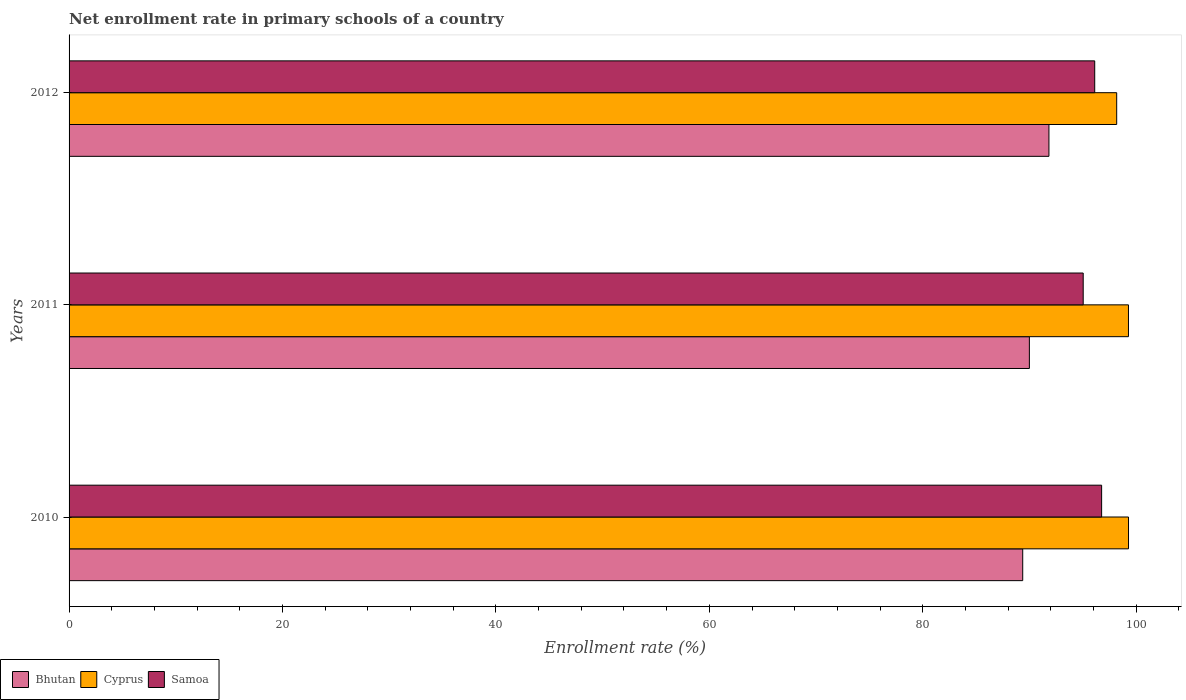How many different coloured bars are there?
Your response must be concise. 3. How many groups of bars are there?
Keep it short and to the point. 3. Are the number of bars on each tick of the Y-axis equal?
Make the answer very short. Yes. How many bars are there on the 1st tick from the top?
Keep it short and to the point. 3. How many bars are there on the 1st tick from the bottom?
Provide a short and direct response. 3. What is the label of the 3rd group of bars from the top?
Make the answer very short. 2010. What is the enrollment rate in primary schools in Bhutan in 2010?
Offer a terse response. 89.37. Across all years, what is the maximum enrollment rate in primary schools in Bhutan?
Your answer should be very brief. 91.83. Across all years, what is the minimum enrollment rate in primary schools in Cyprus?
Provide a short and direct response. 98.18. In which year was the enrollment rate in primary schools in Cyprus maximum?
Your response must be concise. 2010. What is the total enrollment rate in primary schools in Cyprus in the graph?
Ensure brevity in your answer.  296.74. What is the difference between the enrollment rate in primary schools in Cyprus in 2011 and that in 2012?
Offer a very short reply. 1.1. What is the difference between the enrollment rate in primary schools in Bhutan in 2011 and the enrollment rate in primary schools in Cyprus in 2012?
Ensure brevity in your answer.  -8.18. What is the average enrollment rate in primary schools in Samoa per year?
Ensure brevity in your answer.  95.97. In the year 2011, what is the difference between the enrollment rate in primary schools in Bhutan and enrollment rate in primary schools in Cyprus?
Your response must be concise. -9.29. What is the ratio of the enrollment rate in primary schools in Samoa in 2011 to that in 2012?
Give a very brief answer. 0.99. Is the difference between the enrollment rate in primary schools in Bhutan in 2010 and 2011 greater than the difference between the enrollment rate in primary schools in Cyprus in 2010 and 2011?
Make the answer very short. No. What is the difference between the highest and the second highest enrollment rate in primary schools in Samoa?
Your answer should be compact. 0.65. What is the difference between the highest and the lowest enrollment rate in primary schools in Cyprus?
Your answer should be compact. 1.11. In how many years, is the enrollment rate in primary schools in Samoa greater than the average enrollment rate in primary schools in Samoa taken over all years?
Offer a very short reply. 2. What does the 1st bar from the top in 2011 represents?
Make the answer very short. Samoa. What does the 3rd bar from the bottom in 2012 represents?
Offer a very short reply. Samoa. Is it the case that in every year, the sum of the enrollment rate in primary schools in Samoa and enrollment rate in primary schools in Bhutan is greater than the enrollment rate in primary schools in Cyprus?
Provide a succinct answer. Yes. Are all the bars in the graph horizontal?
Your answer should be compact. Yes. Does the graph contain any zero values?
Your response must be concise. No. Does the graph contain grids?
Make the answer very short. No. Where does the legend appear in the graph?
Offer a terse response. Bottom left. What is the title of the graph?
Give a very brief answer. Net enrollment rate in primary schools of a country. Does "French Polynesia" appear as one of the legend labels in the graph?
Ensure brevity in your answer.  No. What is the label or title of the X-axis?
Ensure brevity in your answer.  Enrollment rate (%). What is the label or title of the Y-axis?
Your answer should be compact. Years. What is the Enrollment rate (%) of Bhutan in 2010?
Keep it short and to the point. 89.37. What is the Enrollment rate (%) in Cyprus in 2010?
Keep it short and to the point. 99.29. What is the Enrollment rate (%) in Samoa in 2010?
Provide a succinct answer. 96.77. What is the Enrollment rate (%) of Bhutan in 2011?
Offer a terse response. 89.99. What is the Enrollment rate (%) in Cyprus in 2011?
Make the answer very short. 99.28. What is the Enrollment rate (%) of Samoa in 2011?
Ensure brevity in your answer.  95.04. What is the Enrollment rate (%) in Bhutan in 2012?
Your response must be concise. 91.83. What is the Enrollment rate (%) of Cyprus in 2012?
Keep it short and to the point. 98.18. What is the Enrollment rate (%) in Samoa in 2012?
Ensure brevity in your answer.  96.12. Across all years, what is the maximum Enrollment rate (%) of Bhutan?
Your answer should be very brief. 91.83. Across all years, what is the maximum Enrollment rate (%) of Cyprus?
Offer a very short reply. 99.29. Across all years, what is the maximum Enrollment rate (%) in Samoa?
Ensure brevity in your answer.  96.77. Across all years, what is the minimum Enrollment rate (%) of Bhutan?
Make the answer very short. 89.37. Across all years, what is the minimum Enrollment rate (%) in Cyprus?
Give a very brief answer. 98.18. Across all years, what is the minimum Enrollment rate (%) of Samoa?
Provide a succinct answer. 95.04. What is the total Enrollment rate (%) of Bhutan in the graph?
Your answer should be compact. 271.19. What is the total Enrollment rate (%) of Cyprus in the graph?
Give a very brief answer. 296.74. What is the total Enrollment rate (%) in Samoa in the graph?
Your answer should be compact. 287.92. What is the difference between the Enrollment rate (%) in Bhutan in 2010 and that in 2011?
Make the answer very short. -0.62. What is the difference between the Enrollment rate (%) of Cyprus in 2010 and that in 2011?
Your answer should be compact. 0.01. What is the difference between the Enrollment rate (%) in Samoa in 2010 and that in 2011?
Provide a succinct answer. 1.73. What is the difference between the Enrollment rate (%) in Bhutan in 2010 and that in 2012?
Provide a succinct answer. -2.46. What is the difference between the Enrollment rate (%) of Cyprus in 2010 and that in 2012?
Your answer should be compact. 1.11. What is the difference between the Enrollment rate (%) of Samoa in 2010 and that in 2012?
Offer a terse response. 0.65. What is the difference between the Enrollment rate (%) in Bhutan in 2011 and that in 2012?
Give a very brief answer. -1.83. What is the difference between the Enrollment rate (%) in Cyprus in 2011 and that in 2012?
Offer a terse response. 1.1. What is the difference between the Enrollment rate (%) in Samoa in 2011 and that in 2012?
Ensure brevity in your answer.  -1.08. What is the difference between the Enrollment rate (%) of Bhutan in 2010 and the Enrollment rate (%) of Cyprus in 2011?
Provide a succinct answer. -9.91. What is the difference between the Enrollment rate (%) in Bhutan in 2010 and the Enrollment rate (%) in Samoa in 2011?
Offer a very short reply. -5.67. What is the difference between the Enrollment rate (%) of Cyprus in 2010 and the Enrollment rate (%) of Samoa in 2011?
Your response must be concise. 4.25. What is the difference between the Enrollment rate (%) of Bhutan in 2010 and the Enrollment rate (%) of Cyprus in 2012?
Your answer should be compact. -8.81. What is the difference between the Enrollment rate (%) in Bhutan in 2010 and the Enrollment rate (%) in Samoa in 2012?
Offer a terse response. -6.75. What is the difference between the Enrollment rate (%) in Cyprus in 2010 and the Enrollment rate (%) in Samoa in 2012?
Offer a terse response. 3.17. What is the difference between the Enrollment rate (%) in Bhutan in 2011 and the Enrollment rate (%) in Cyprus in 2012?
Give a very brief answer. -8.18. What is the difference between the Enrollment rate (%) of Bhutan in 2011 and the Enrollment rate (%) of Samoa in 2012?
Keep it short and to the point. -6.12. What is the difference between the Enrollment rate (%) of Cyprus in 2011 and the Enrollment rate (%) of Samoa in 2012?
Make the answer very short. 3.16. What is the average Enrollment rate (%) of Bhutan per year?
Offer a terse response. 90.4. What is the average Enrollment rate (%) of Cyprus per year?
Provide a short and direct response. 98.91. What is the average Enrollment rate (%) in Samoa per year?
Offer a very short reply. 95.97. In the year 2010, what is the difference between the Enrollment rate (%) of Bhutan and Enrollment rate (%) of Cyprus?
Ensure brevity in your answer.  -9.91. In the year 2010, what is the difference between the Enrollment rate (%) in Bhutan and Enrollment rate (%) in Samoa?
Give a very brief answer. -7.39. In the year 2010, what is the difference between the Enrollment rate (%) in Cyprus and Enrollment rate (%) in Samoa?
Keep it short and to the point. 2.52. In the year 2011, what is the difference between the Enrollment rate (%) of Bhutan and Enrollment rate (%) of Cyprus?
Your answer should be very brief. -9.29. In the year 2011, what is the difference between the Enrollment rate (%) of Bhutan and Enrollment rate (%) of Samoa?
Your response must be concise. -5.04. In the year 2011, what is the difference between the Enrollment rate (%) of Cyprus and Enrollment rate (%) of Samoa?
Provide a short and direct response. 4.24. In the year 2012, what is the difference between the Enrollment rate (%) in Bhutan and Enrollment rate (%) in Cyprus?
Offer a very short reply. -6.35. In the year 2012, what is the difference between the Enrollment rate (%) of Bhutan and Enrollment rate (%) of Samoa?
Give a very brief answer. -4.29. In the year 2012, what is the difference between the Enrollment rate (%) in Cyprus and Enrollment rate (%) in Samoa?
Make the answer very short. 2.06. What is the ratio of the Enrollment rate (%) of Samoa in 2010 to that in 2011?
Provide a short and direct response. 1.02. What is the ratio of the Enrollment rate (%) in Bhutan in 2010 to that in 2012?
Provide a succinct answer. 0.97. What is the ratio of the Enrollment rate (%) in Cyprus in 2010 to that in 2012?
Provide a short and direct response. 1.01. What is the ratio of the Enrollment rate (%) of Samoa in 2010 to that in 2012?
Offer a terse response. 1.01. What is the ratio of the Enrollment rate (%) of Bhutan in 2011 to that in 2012?
Provide a short and direct response. 0.98. What is the ratio of the Enrollment rate (%) in Cyprus in 2011 to that in 2012?
Your answer should be compact. 1.01. What is the difference between the highest and the second highest Enrollment rate (%) of Bhutan?
Your answer should be compact. 1.83. What is the difference between the highest and the second highest Enrollment rate (%) of Cyprus?
Keep it short and to the point. 0.01. What is the difference between the highest and the second highest Enrollment rate (%) of Samoa?
Give a very brief answer. 0.65. What is the difference between the highest and the lowest Enrollment rate (%) in Bhutan?
Provide a succinct answer. 2.46. What is the difference between the highest and the lowest Enrollment rate (%) of Cyprus?
Provide a succinct answer. 1.11. What is the difference between the highest and the lowest Enrollment rate (%) in Samoa?
Give a very brief answer. 1.73. 